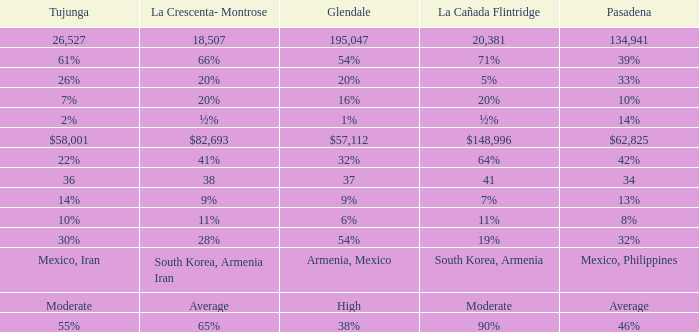If la crescenta-montrose constitutes 28%, what is the corresponding percentage for tukunga? 30%. Parse the full table. {'header': ['Tujunga', 'La Crescenta- Montrose', 'Glendale', 'La Cañada Flintridge', 'Pasadena'], 'rows': [['26,527', '18,507', '195,047', '20,381', '134,941'], ['61%', '66%', '54%', '71%', '39%'], ['26%', '20%', '20%', '5%', '33%'], ['7%', '20%', '16%', '20%', '10%'], ['2%', '½%', '1%', '½%', '14%'], ['$58,001', '$82,693', '$57,112', '$148,996', '$62,825'], ['22%', '41%', '32%', '64%', '42%'], ['36', '38', '37', '41', '34'], ['14%', '9%', '9%', '7%', '13%'], ['10%', '11%', '6%', '11%', '8%'], ['30%', '28%', '54%', '19%', '32%'], ['Mexico, Iran', 'South Korea, Armenia Iran', 'Armenia, Mexico', 'South Korea, Armenia', 'Mexico, Philippines'], ['Moderate', 'Average', 'High', 'Moderate', 'Average'], ['55%', '65%', '38%', '90%', '46%']]} 